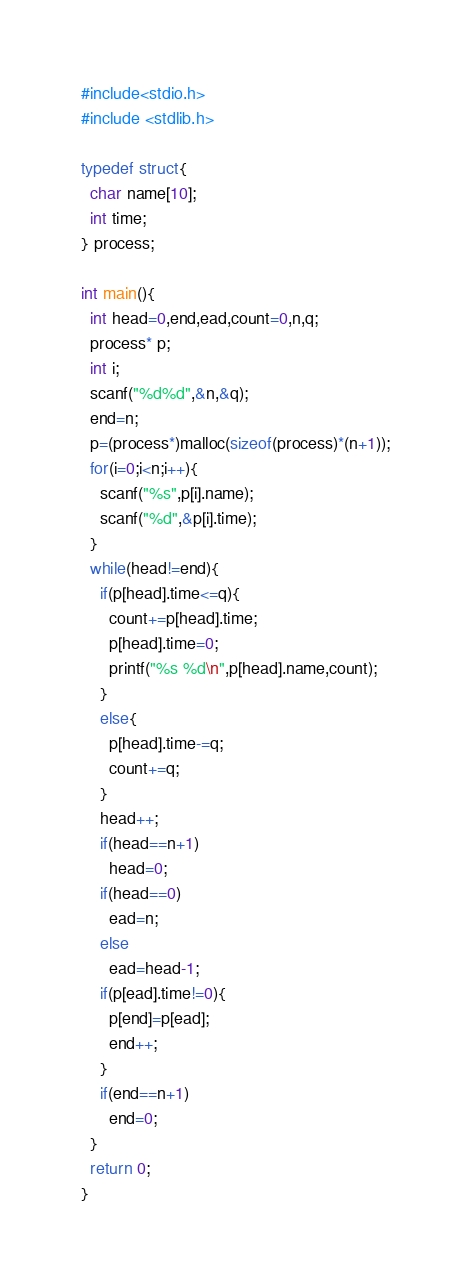<code> <loc_0><loc_0><loc_500><loc_500><_C_>#include<stdio.h>
#include <stdlib.h>

typedef struct{
  char name[10];
  int time;
} process;

int main(){
  int head=0,end,ead,count=0,n,q;
  process* p;
  int i;
  scanf("%d%d",&n,&q);
  end=n;
  p=(process*)malloc(sizeof(process)*(n+1));
  for(i=0;i<n;i++){
    scanf("%s",p[i].name);
    scanf("%d",&p[i].time);
  }
  while(head!=end){
    if(p[head].time<=q){
      count+=p[head].time;
      p[head].time=0;
      printf("%s %d\n",p[head].name,count);
    }
    else{
      p[head].time-=q;
      count+=q;
    }
    head++;
    if(head==n+1)
      head=0;
    if(head==0)
      ead=n;
    else
      ead=head-1;
    if(p[ead].time!=0){
      p[end]=p[ead];
      end++;
    }
    if(end==n+1)
      end=0;
  }  
  return 0;
}</code> 